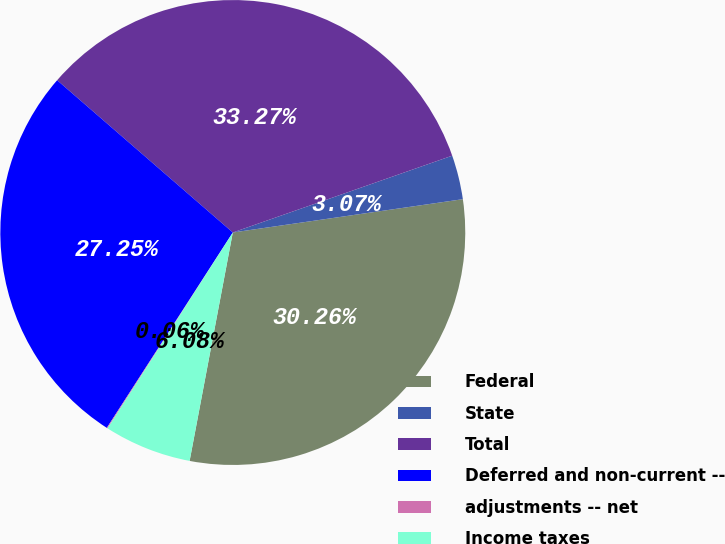Convert chart to OTSL. <chart><loc_0><loc_0><loc_500><loc_500><pie_chart><fcel>Federal<fcel>State<fcel>Total<fcel>Deferred and non-current --<fcel>adjustments -- net<fcel>Income taxes<nl><fcel>30.26%<fcel>3.07%<fcel>33.27%<fcel>27.25%<fcel>0.06%<fcel>6.08%<nl></chart> 